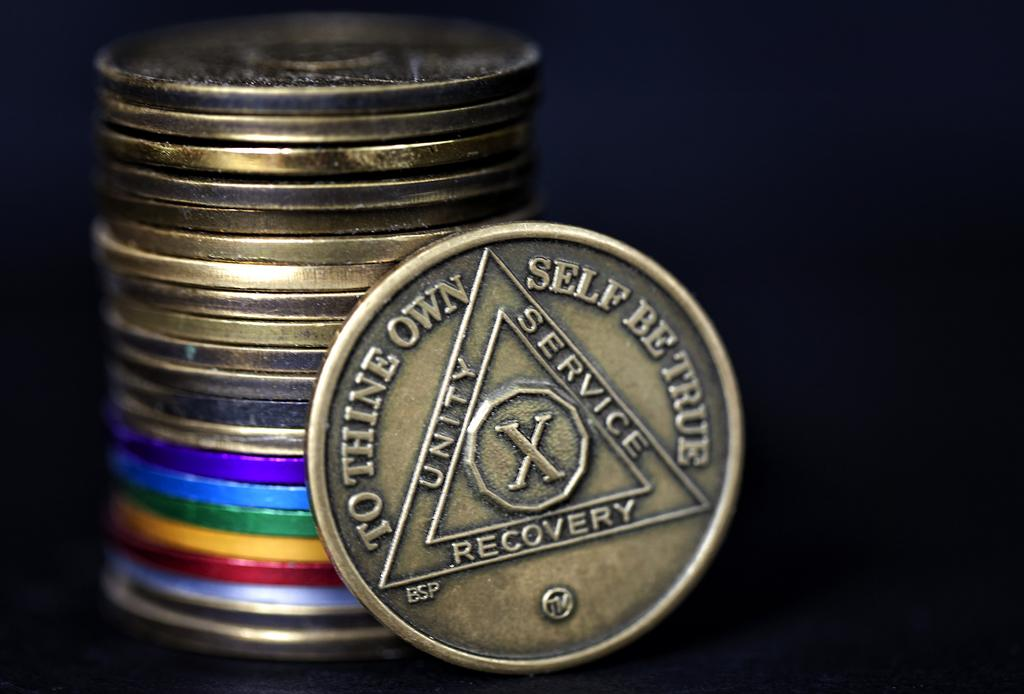<image>
Summarize the visual content of the image. A stack of bronze and colorful coins with one resting against it with the words "To thine own self be true" around the perimeter. 